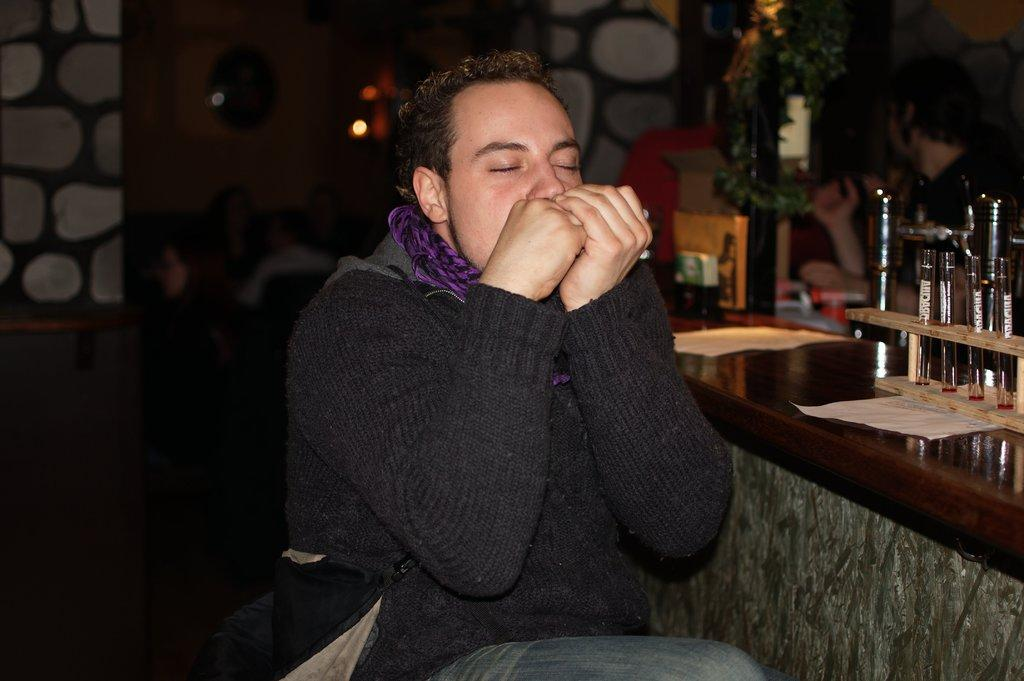What is the man in the image doing? The man is sitting in the image. What can be seen behind the man? There is a table and a wall visible in the background of the image. What is on the table in the background? The table has objects on it. What else can be seen in the background of the image? There are other objects present in the background of the image. What type of stocking is the man wearing on his legs in the image? There is no mention of stockings or legs in the image, so it cannot be determined if the man is wearing stockings or what type they might be. 